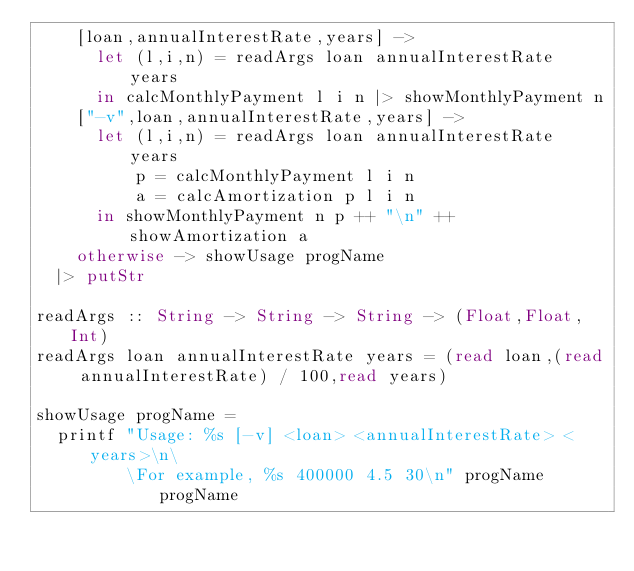Convert code to text. <code><loc_0><loc_0><loc_500><loc_500><_Haskell_>    [loan,annualInterestRate,years] ->
      let (l,i,n) = readArgs loan annualInterestRate years
      in calcMonthlyPayment l i n |> showMonthlyPayment n
    ["-v",loan,annualInterestRate,years] ->
      let (l,i,n) = readArgs loan annualInterestRate years
          p = calcMonthlyPayment l i n
          a = calcAmortization p l i n
      in showMonthlyPayment n p ++ "\n" ++ showAmortization a
    otherwise -> showUsage progName
  |> putStr

readArgs :: String -> String -> String -> (Float,Float,Int)
readArgs loan annualInterestRate years = (read loan,(read annualInterestRate) / 100,read years)

showUsage progName =
  printf "Usage: %s [-v] <loan> <annualInterestRate> <years>\n\
         \For example, %s 400000 4.5 30\n" progName progName
</code> 